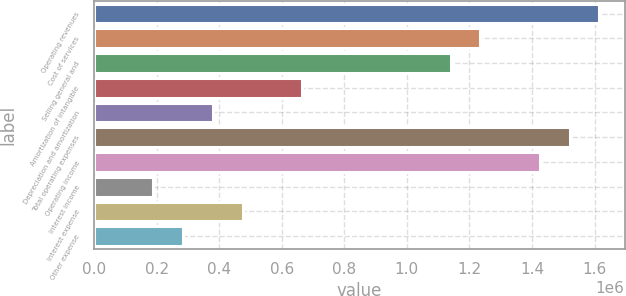Convert chart. <chart><loc_0><loc_0><loc_500><loc_500><bar_chart><fcel>Operating revenues<fcel>Cost of services<fcel>Selling general and<fcel>Amortization of intangible<fcel>Depreciation and amortization<fcel>Total operating expenses<fcel>Operating income<fcel>Interest income<fcel>Interest expense<fcel>Other expense<nl><fcel>1.61524e+06<fcel>1.23518e+06<fcel>1.14017e+06<fcel>665099<fcel>380057<fcel>1.52022e+06<fcel>1.42521e+06<fcel>190029<fcel>475071<fcel>285043<nl></chart> 